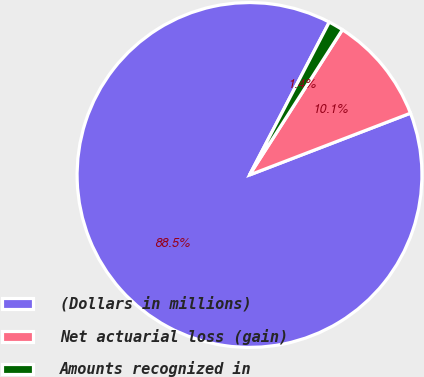<chart> <loc_0><loc_0><loc_500><loc_500><pie_chart><fcel>(Dollars in millions)<fcel>Net actuarial loss (gain)<fcel>Amounts recognized in<nl><fcel>88.48%<fcel>10.11%<fcel>1.4%<nl></chart> 